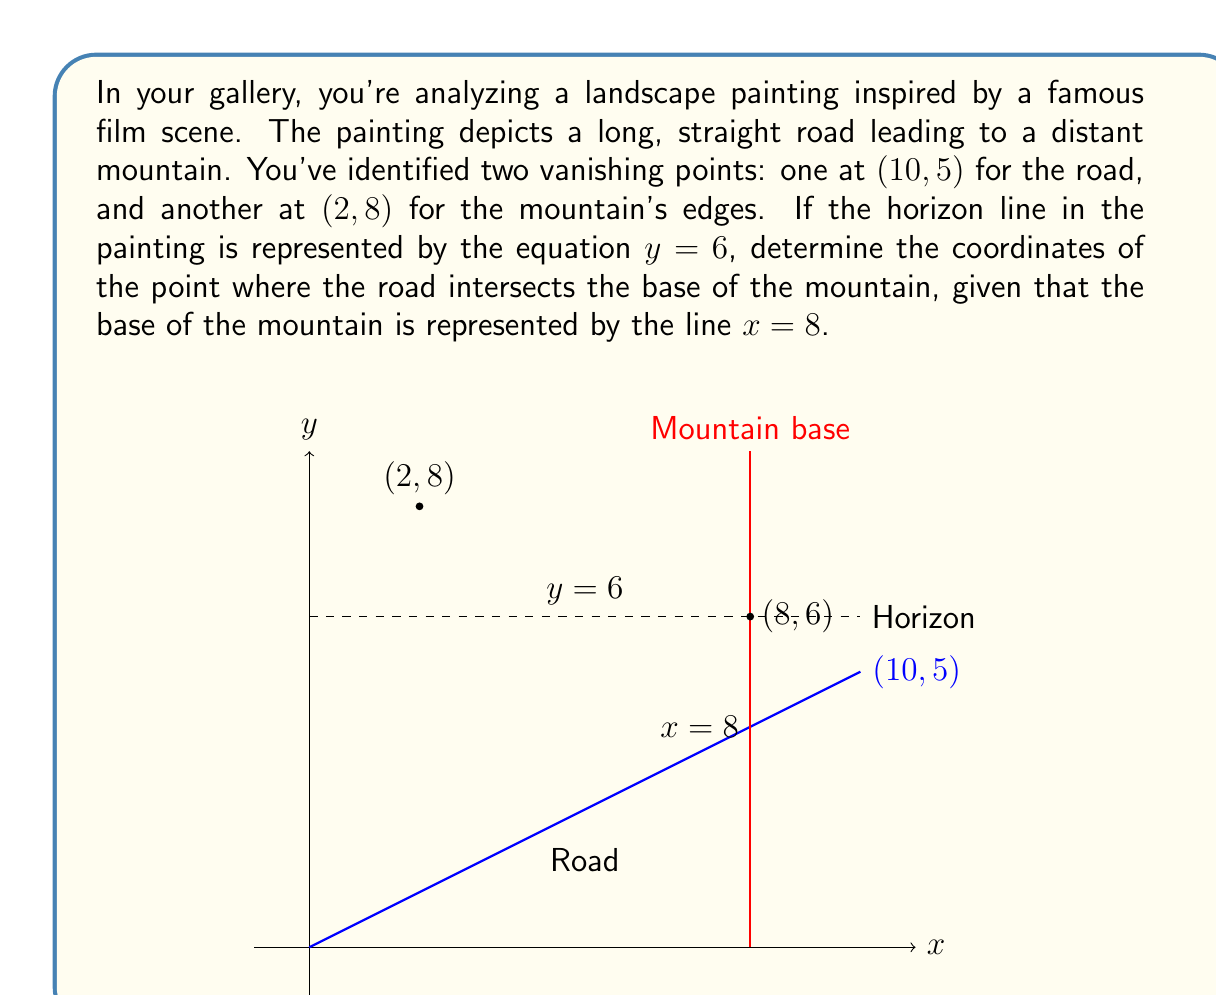Give your solution to this math problem. Let's approach this step-by-step:

1) The road is a line passing through the origin (0,0) and the vanishing point (10,5). We can find its equation using the point-slope form:

   $y - y_1 = m(x - x_1)$

   Where $m = \frac{y_2 - y_1}{x_2 - x_1} = \frac{5 - 0}{10 - 0} = \frac{1}{2}$

   So the equation of the road is:
   $y - 0 = \frac{1}{2}(x - 0)$
   $y = \frac{1}{2}x$

2) The base of the mountain is a vertical line at $x = 8$.

3) To find the intersection point, we substitute $x = 8$ into the road equation:

   $y = \frac{1}{2}(8) = 4$

4) Therefore, the intersection point is (8, 4).

5) We need to check if this point is below the horizon line ($y = 6$):
   Since 4 < 6, the intersection point is indeed below the horizon.

Thus, the coordinates of the point where the road intersects the base of the mountain are (8, 4).
Answer: (8, 4) 